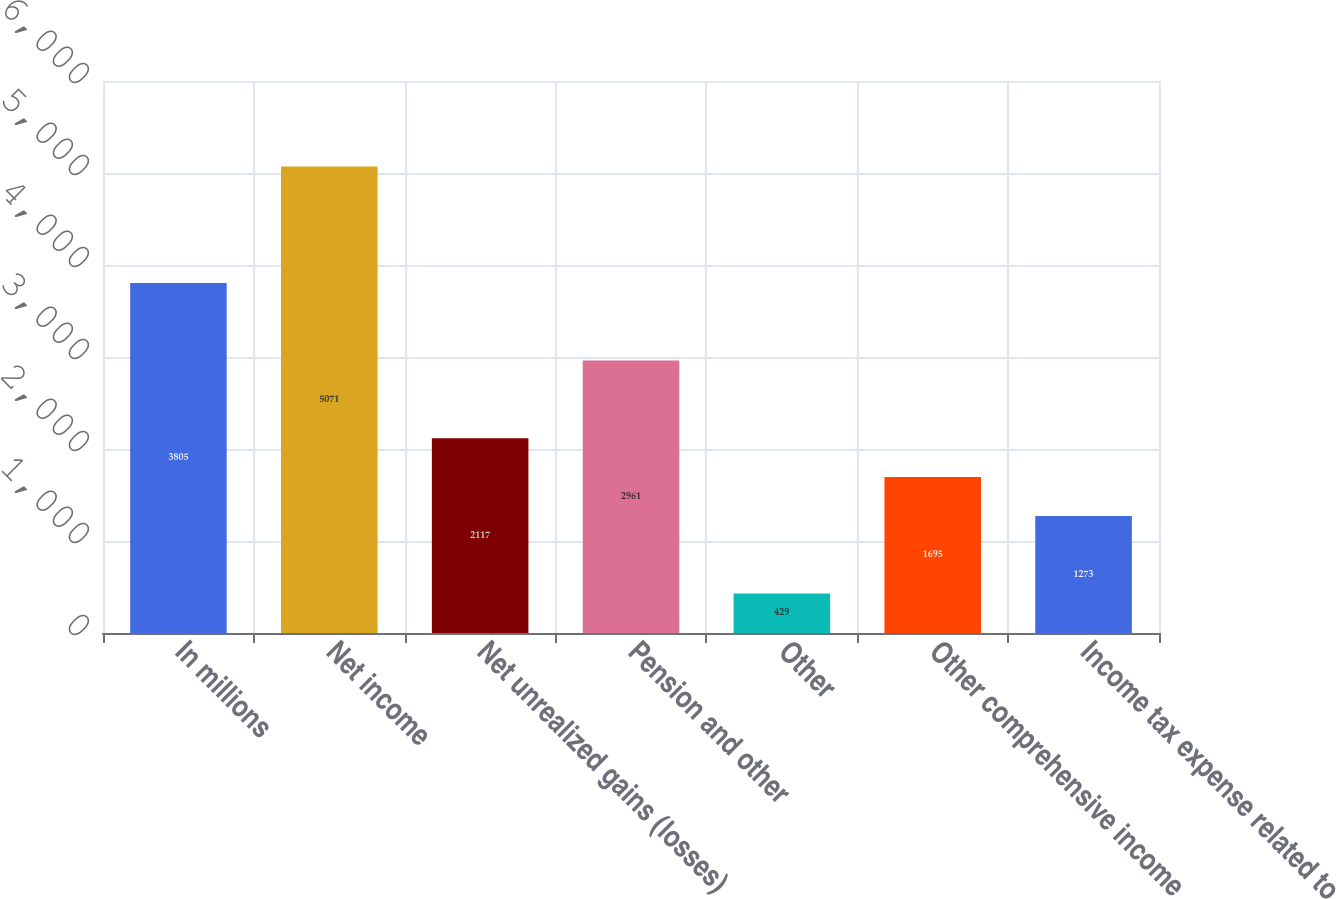Convert chart to OTSL. <chart><loc_0><loc_0><loc_500><loc_500><bar_chart><fcel>In millions<fcel>Net income<fcel>Net unrealized gains (losses)<fcel>Pension and other<fcel>Other<fcel>Other comprehensive income<fcel>Income tax expense related to<nl><fcel>3805<fcel>5071<fcel>2117<fcel>2961<fcel>429<fcel>1695<fcel>1273<nl></chart> 